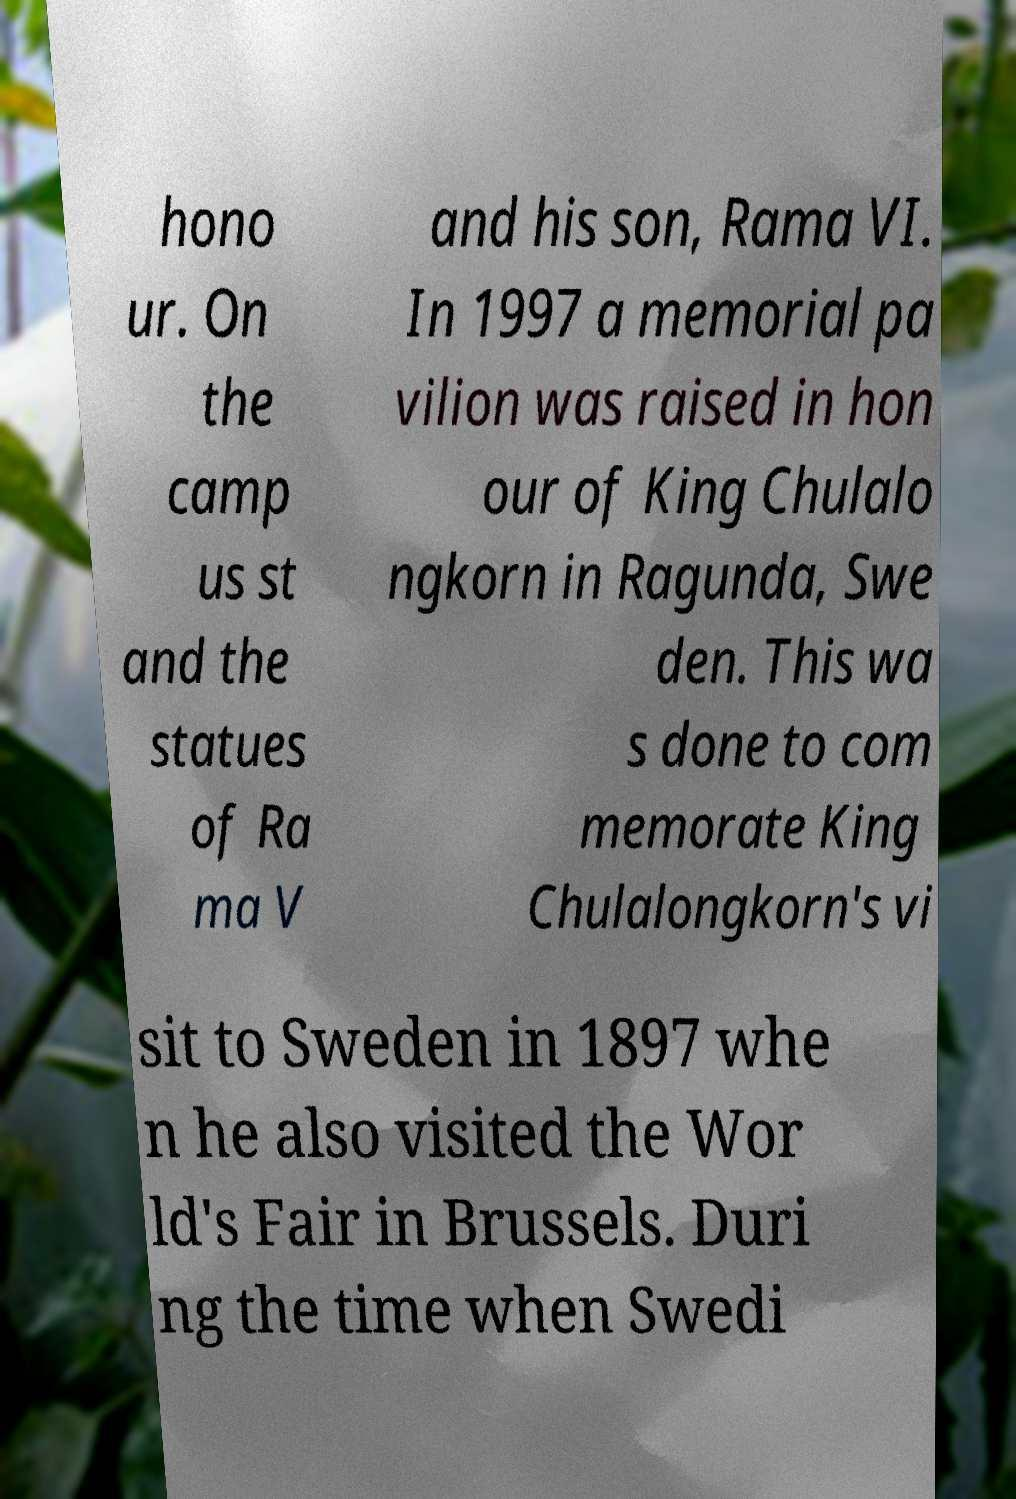For documentation purposes, I need the text within this image transcribed. Could you provide that? hono ur. On the camp us st and the statues of Ra ma V and his son, Rama VI. In 1997 a memorial pa vilion was raised in hon our of King Chulalo ngkorn in Ragunda, Swe den. This wa s done to com memorate King Chulalongkorn's vi sit to Sweden in 1897 whe n he also visited the Wor ld's Fair in Brussels. Duri ng the time when Swedi 